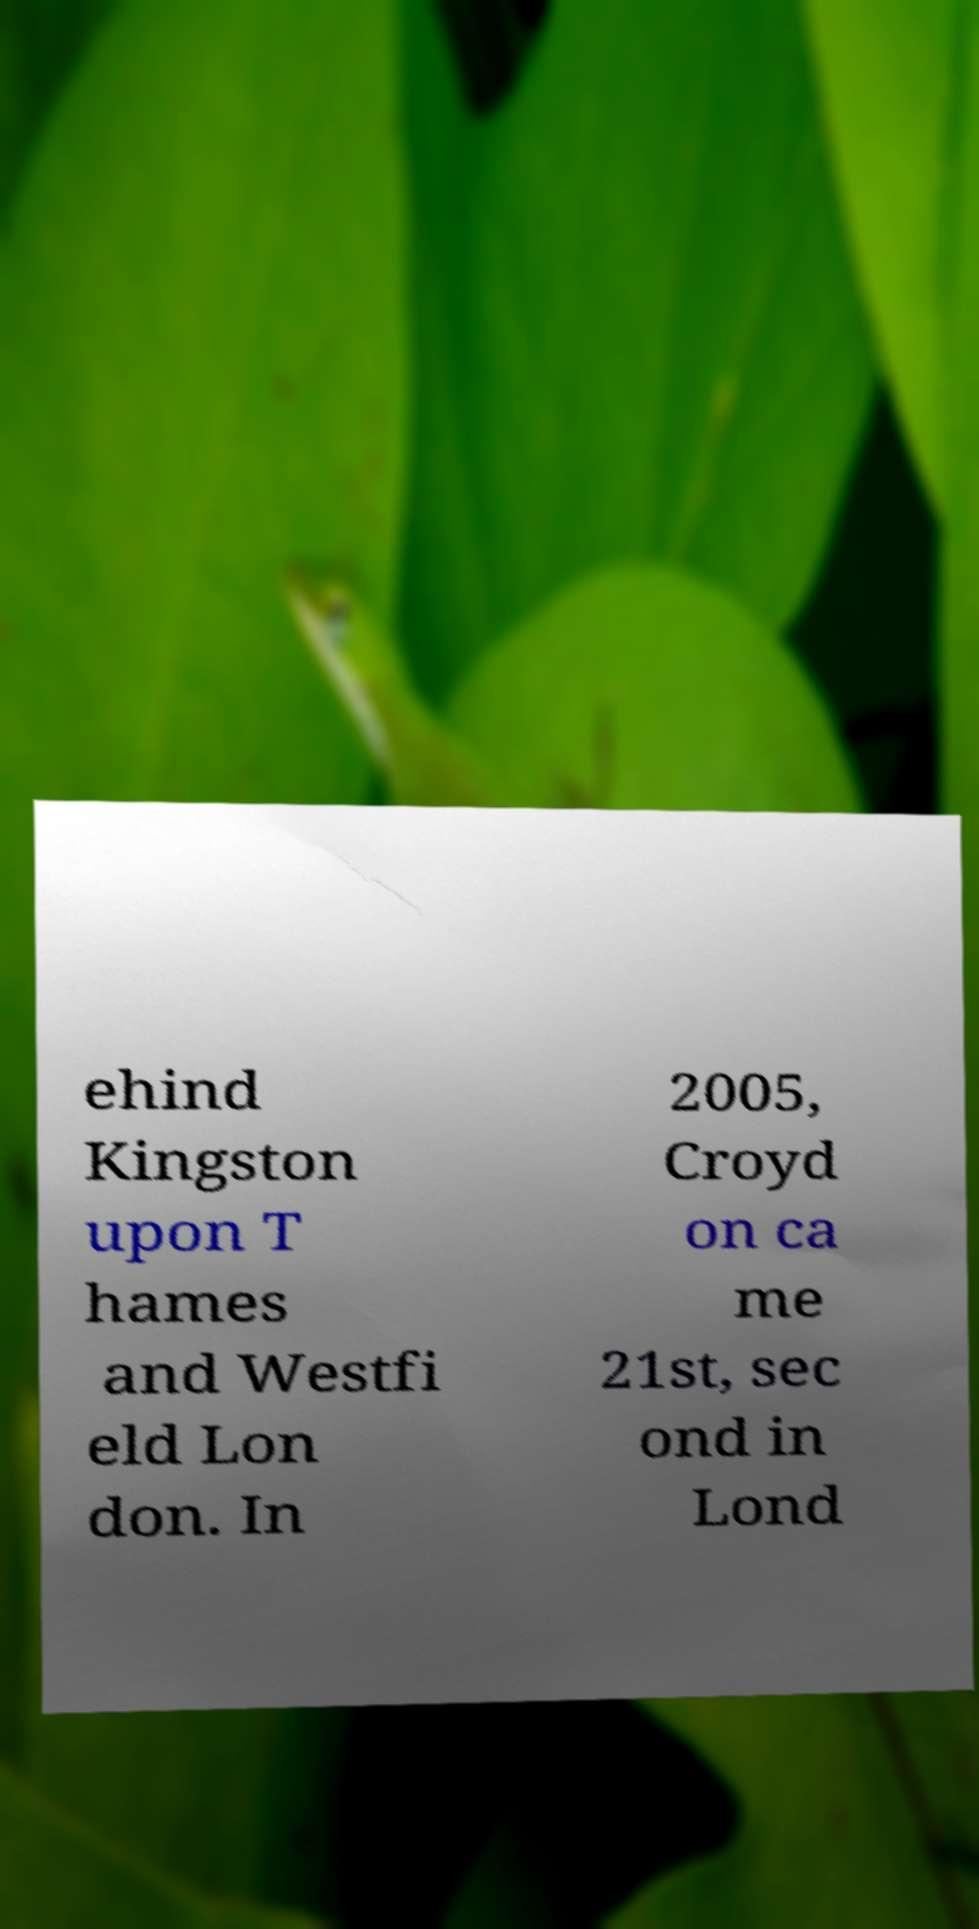What messages or text are displayed in this image? I need them in a readable, typed format. ehind Kingston upon T hames and Westfi eld Lon don. In 2005, Croyd on ca me 21st, sec ond in Lond 